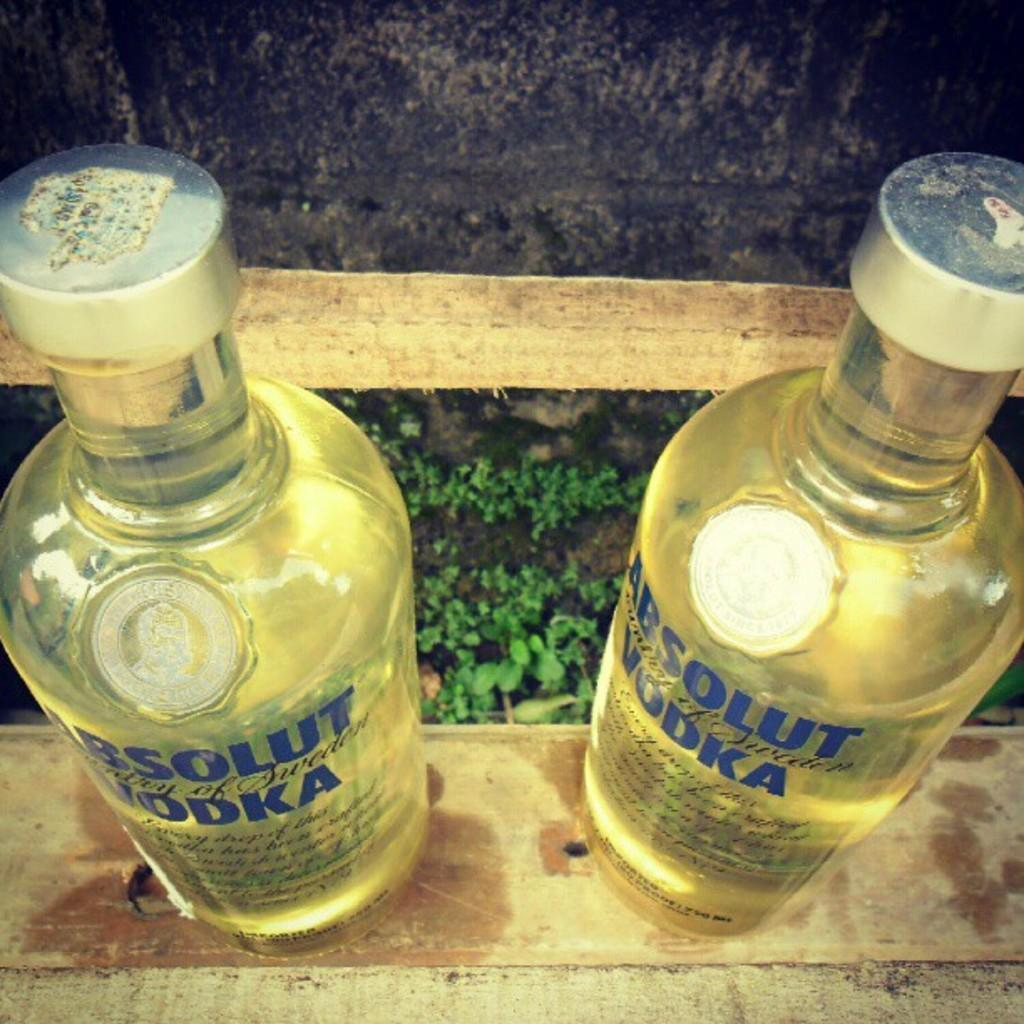<image>
Write a terse but informative summary of the picture. Two bottles of Absolut Vodka sit side by side on a wooden plank. 